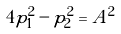<formula> <loc_0><loc_0><loc_500><loc_500>4 p _ { 1 } ^ { 2 } - p _ { 2 } ^ { 2 } = A ^ { 2 }</formula> 